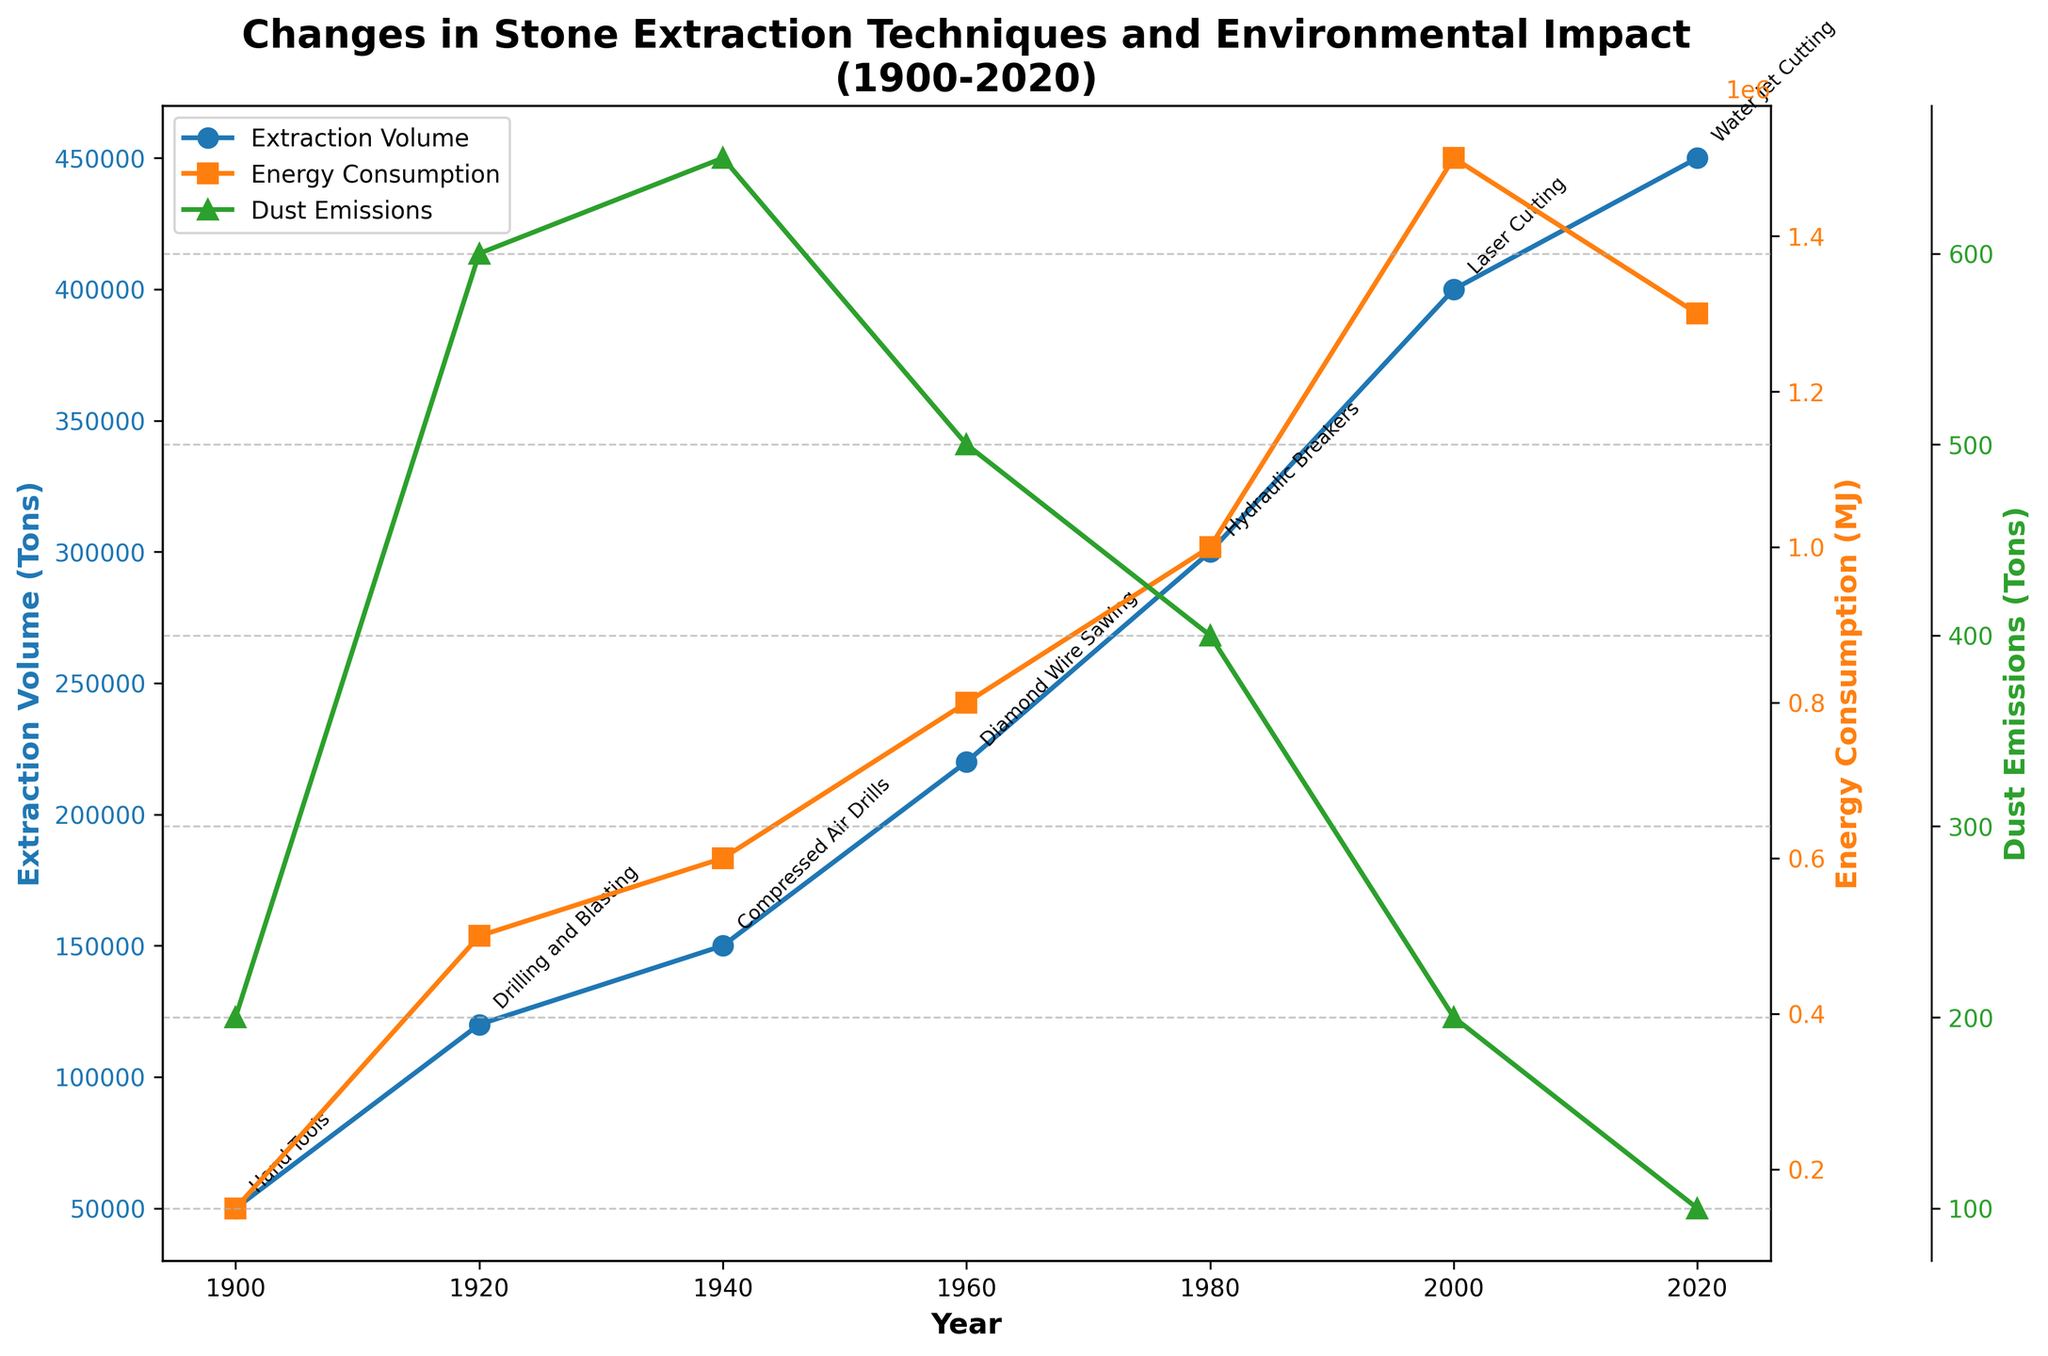What is the title of the figure? The title of the figure is written at the top of the plot and provides an overview of what the plot represents.
Answer: Changes in Stone Extraction Techniques and Environmental Impact (1900-2020) How many distinct extraction techniques are mentioned in the plot? By counting the number of different extraction techniques annotated on the plot, we find there are seven.
Answer: 7 Which year saw the highest extraction volume? By looking at the plot line for extraction volume, we see that the highest point is in the year 2020.
Answer: 2020 Between which years did the energy consumption increase the most? Observing the plot for energy consumption, the largest increase in energy is between 1980 and 2000.
Answer: 1980 to 2000 How did the dust emissions change from 1940 to 2020? By following the plot line for dust emissions between these years, it can be noted that emissions decreased from 650 tons in 1940 to 100 tons in 2020.
Answer: Decreased What is the extraction technique used in 2000, and what is its corresponding extraction volume? Annotating the year 2000, the technique is Laser Cutting, and the corresponding extraction volume at that point on the plot is 400,000 tons.
Answer: Laser Cutting, 400,000 tons Does the noise level increase or decrease over time? By tracking the noise level data points through time, it can be seen that the noise level generally increases from 75 dB in 1900 to 80 dB in 2020.
Answer: Increases Compare the energy consumption in 1960 with 2000. How much more or less is it in 2000? The energy consumption in 1960 is 800,000 MJ, and in 2000, it's 1,500,000 MJ. The difference is 1,500,000 - 800,000 = 700,000 MJ more in 2000.
Answer: 700,000 MJ more Which extraction technique is associated with the highest dust emissions and in what year? By examining the dust emissions plot, the highest emissions are 650 tons in 1940 associated with Compressed Air Drills.
Answer: Compressed Air Drills, 1940 What is the trend of water usage from 1900 to 2020? Observing the water usage data points from the beginning to the end of the time series, we see an increasing trend, from 50,000 liters in 1900 to 280,000 liters in 2020.
Answer: Increasing 